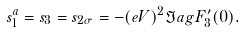<formula> <loc_0><loc_0><loc_500><loc_500>s _ { 1 } ^ { a } = s _ { 3 } = s _ { 2 \sigma } = - ( e V ) ^ { 2 } \Im a g F ^ { \prime } _ { 3 } ( 0 ) .</formula> 